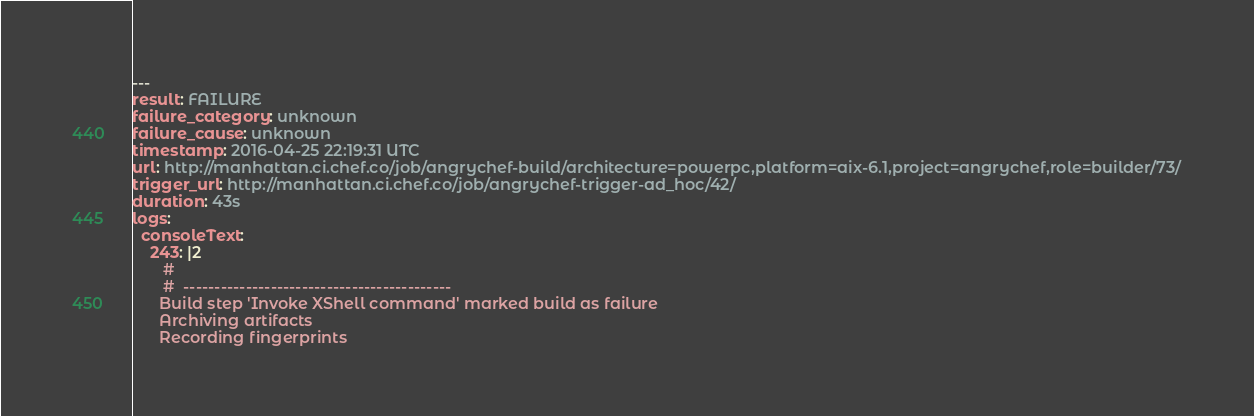Convert code to text. <code><loc_0><loc_0><loc_500><loc_500><_YAML_>---
result: FAILURE
failure_category: unknown
failure_cause: unknown
timestamp: 2016-04-25 22:19:31 UTC
url: http://manhattan.ci.chef.co/job/angrychef-build/architecture=powerpc,platform=aix-6.1,project=angrychef,role=builder/73/
trigger_url: http://manhattan.ci.chef.co/job/angrychef-trigger-ad_hoc/42/
duration: 43s
logs:
  consoleText:
    243: |2
       #
       #  -------------------------------------------
      Build step 'Invoke XShell command' marked build as failure
      Archiving artifacts
      Recording fingerprints
</code> 